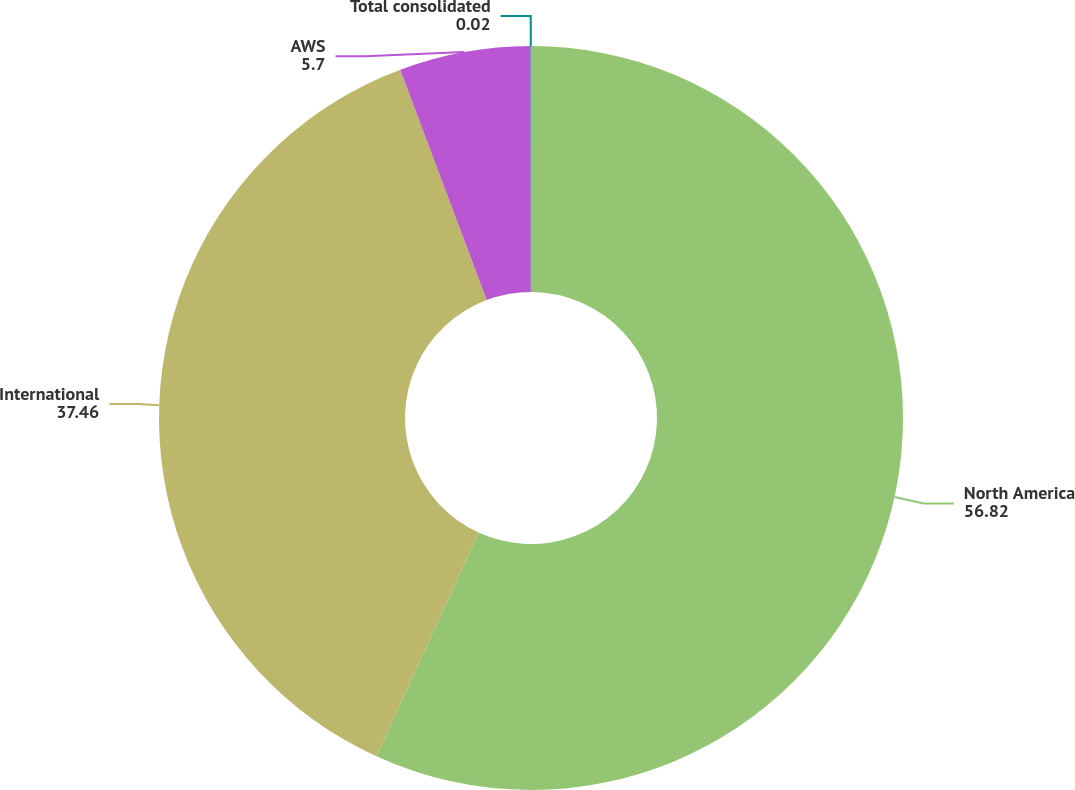Convert chart to OTSL. <chart><loc_0><loc_0><loc_500><loc_500><pie_chart><fcel>North America<fcel>International<fcel>AWS<fcel>Total consolidated<nl><fcel>56.82%<fcel>37.46%<fcel>5.7%<fcel>0.02%<nl></chart> 